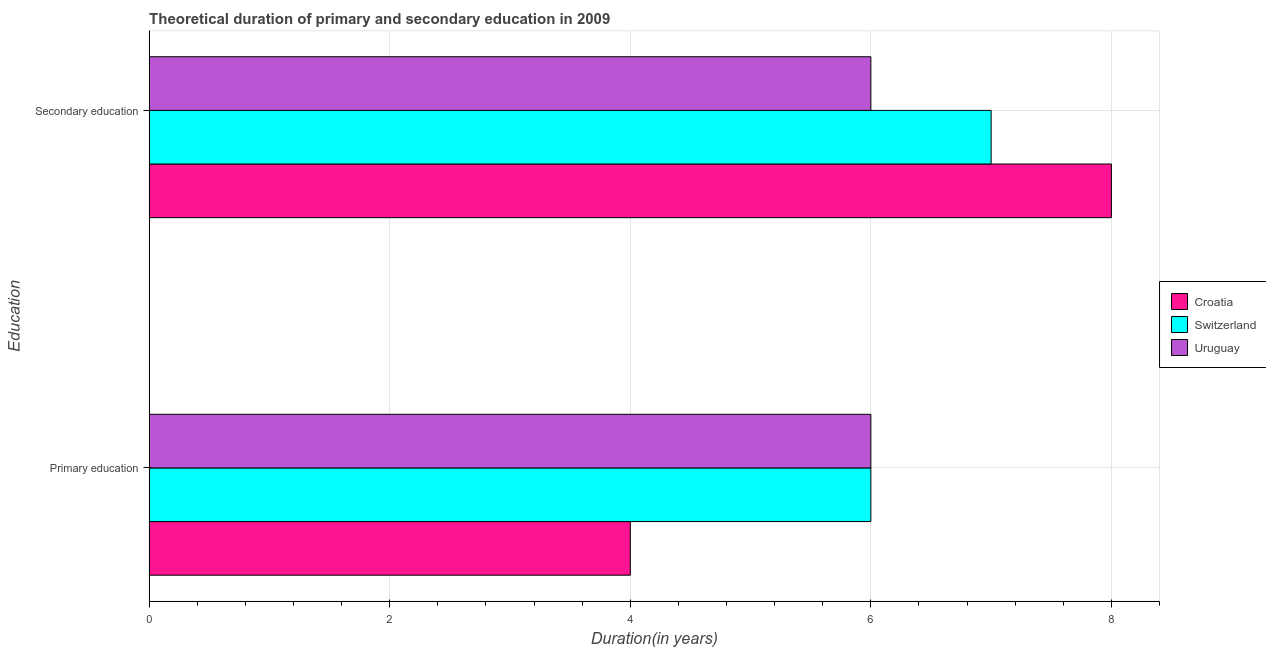Are the number of bars on each tick of the Y-axis equal?
Your response must be concise. Yes. What is the label of the 2nd group of bars from the top?
Give a very brief answer. Primary education. Across all countries, what is the maximum duration of primary education?
Keep it short and to the point. 6. Across all countries, what is the minimum duration of primary education?
Your answer should be compact. 4. In which country was the duration of secondary education maximum?
Offer a terse response. Croatia. In which country was the duration of secondary education minimum?
Ensure brevity in your answer.  Uruguay. What is the total duration of primary education in the graph?
Give a very brief answer. 16. What is the difference between the duration of secondary education in Croatia and that in Uruguay?
Your response must be concise. 2. What is the difference between the duration of primary education in Uruguay and the duration of secondary education in Switzerland?
Your answer should be compact. -1. What is the average duration of primary education per country?
Your answer should be compact. 5.33. What is the difference between the duration of primary education and duration of secondary education in Croatia?
Provide a short and direct response. -4. In how many countries, is the duration of secondary education greater than 3.6 years?
Provide a short and direct response. 3. What is the ratio of the duration of secondary education in Croatia to that in Switzerland?
Provide a short and direct response. 1.14. Is the duration of primary education in Croatia less than that in Switzerland?
Provide a succinct answer. Yes. What does the 1st bar from the top in Primary education represents?
Provide a succinct answer. Uruguay. What does the 3rd bar from the bottom in Secondary education represents?
Offer a terse response. Uruguay. What is the difference between two consecutive major ticks on the X-axis?
Provide a succinct answer. 2. Are the values on the major ticks of X-axis written in scientific E-notation?
Your response must be concise. No. Does the graph contain any zero values?
Ensure brevity in your answer.  No. Does the graph contain grids?
Ensure brevity in your answer.  Yes. How many legend labels are there?
Your answer should be very brief. 3. How are the legend labels stacked?
Provide a short and direct response. Vertical. What is the title of the graph?
Provide a short and direct response. Theoretical duration of primary and secondary education in 2009. What is the label or title of the X-axis?
Your response must be concise. Duration(in years). What is the label or title of the Y-axis?
Provide a succinct answer. Education. What is the Duration(in years) in Uruguay in Primary education?
Your answer should be very brief. 6. What is the Duration(in years) in Croatia in Secondary education?
Give a very brief answer. 8. What is the Duration(in years) of Switzerland in Secondary education?
Give a very brief answer. 7. What is the Duration(in years) of Uruguay in Secondary education?
Give a very brief answer. 6. Across all Education, what is the maximum Duration(in years) in Uruguay?
Ensure brevity in your answer.  6. Across all Education, what is the minimum Duration(in years) of Croatia?
Give a very brief answer. 4. Across all Education, what is the minimum Duration(in years) of Switzerland?
Give a very brief answer. 6. Across all Education, what is the minimum Duration(in years) of Uruguay?
Offer a very short reply. 6. What is the total Duration(in years) in Uruguay in the graph?
Your answer should be very brief. 12. What is the difference between the Duration(in years) of Switzerland in Primary education and that in Secondary education?
Provide a short and direct response. -1. What is the difference between the Duration(in years) in Uruguay in Primary education and that in Secondary education?
Your answer should be very brief. 0. What is the difference between the Duration(in years) in Croatia in Primary education and the Duration(in years) in Switzerland in Secondary education?
Provide a succinct answer. -3. What is the difference between the Duration(in years) of Croatia in Primary education and the Duration(in years) of Uruguay in Secondary education?
Provide a succinct answer. -2. What is the average Duration(in years) of Croatia per Education?
Provide a succinct answer. 6. What is the average Duration(in years) of Uruguay per Education?
Your response must be concise. 6. What is the difference between the Duration(in years) in Croatia and Duration(in years) in Uruguay in Primary education?
Keep it short and to the point. -2. What is the difference between the Duration(in years) in Croatia and Duration(in years) in Uruguay in Secondary education?
Your answer should be compact. 2. What is the ratio of the Duration(in years) in Switzerland in Primary education to that in Secondary education?
Give a very brief answer. 0.86. What is the difference between the highest and the lowest Duration(in years) in Croatia?
Offer a terse response. 4. What is the difference between the highest and the lowest Duration(in years) of Switzerland?
Your response must be concise. 1. What is the difference between the highest and the lowest Duration(in years) in Uruguay?
Your response must be concise. 0. 